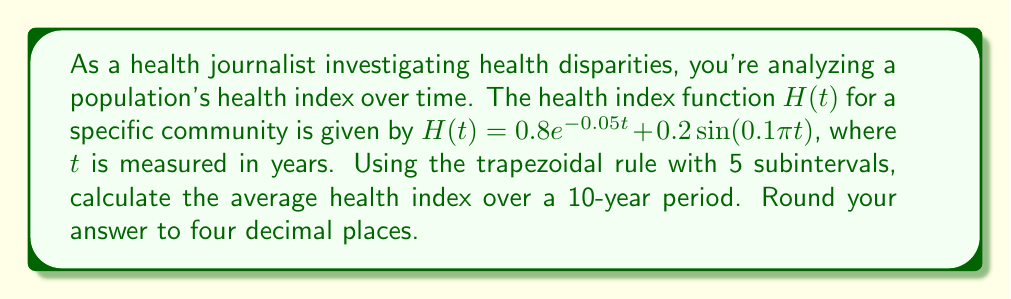Can you solve this math problem? To solve this problem, we'll use the trapezoidal rule for numerical integration:

1) The trapezoidal rule is given by:
   $$\int_a^b f(x)dx \approx \frac{h}{2}\left[f(x_0) + 2f(x_1) + 2f(x_2) + ... + 2f(x_{n-1}) + f(x_n)\right]$$
   where $h = \frac{b-a}{n}$, and $n$ is the number of subintervals.

2) In our case, $a=0$, $b=10$, and $n=5$. So, $h = \frac{10-0}{5} = 2$.

3) We need to evaluate $H(t)$ at $t = 0, 2, 4, 6, 8, 10$:

   $H(0) = 0.8e^0 + 0.2\sin(0) = 0.8$
   $H(2) = 0.8e^{-0.1} + 0.2\sin(0.2\pi) \approx 0.7242$
   $H(4) = 0.8e^{-0.2} + 0.2\sin(0.4\pi) \approx 0.6613$
   $H(6) = 0.8e^{-0.3} + 0.2\sin(0.6\pi) \approx 0.6105$
   $H(8) = 0.8e^{-0.4} + 0.2\sin(0.8\pi) \approx 0.5697$
   $H(10) = 0.8e^{-0.5} + 0.2\sin(\pi) = 0.4866$

4) Applying the trapezoidal rule:
   $$\int_0^{10} H(t)dt \approx \frac{2}{2}[0.8 + 2(0.7242 + 0.6613 + 0.6105 + 0.5697) + 0.4866]$$
   $$\approx 6.5180$$

5) To get the average, we divide by the interval length (10 years):
   $$\text{Average} = \frac{6.5180}{10} = 0.6518$$

Therefore, the average health index over the 10-year period is approximately 0.6518.
Answer: 0.6518 